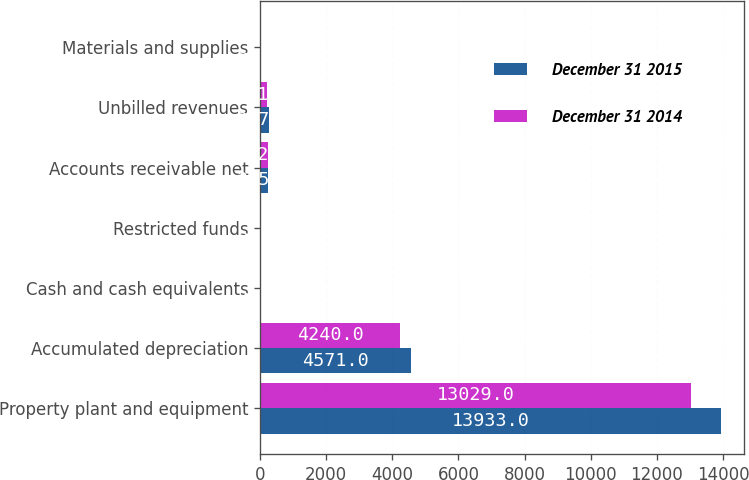Convert chart to OTSL. <chart><loc_0><loc_0><loc_500><loc_500><stacked_bar_chart><ecel><fcel>Property plant and equipment<fcel>Accumulated depreciation<fcel>Cash and cash equivalents<fcel>Restricted funds<fcel>Accounts receivable net<fcel>Unbilled revenues<fcel>Materials and supplies<nl><fcel>December 31 2015<fcel>13933<fcel>4571<fcel>45<fcel>21<fcel>255<fcel>267<fcel>38<nl><fcel>December 31 2014<fcel>13029<fcel>4240<fcel>23<fcel>14<fcel>232<fcel>221<fcel>37<nl></chart> 